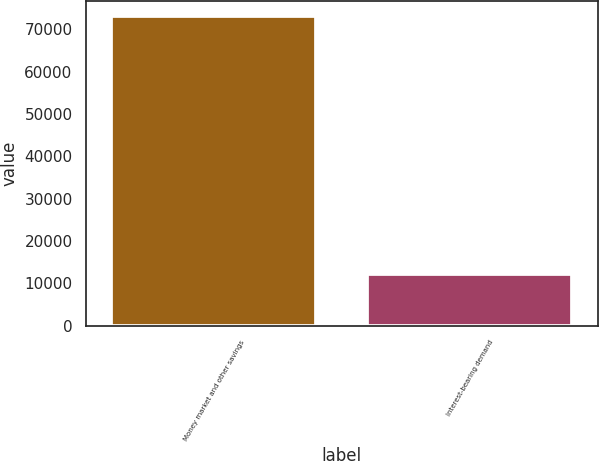Convert chart. <chart><loc_0><loc_0><loc_500><loc_500><bar_chart><fcel>Money market and other savings<fcel>Interest-bearing demand<nl><fcel>73167<fcel>12298<nl></chart> 